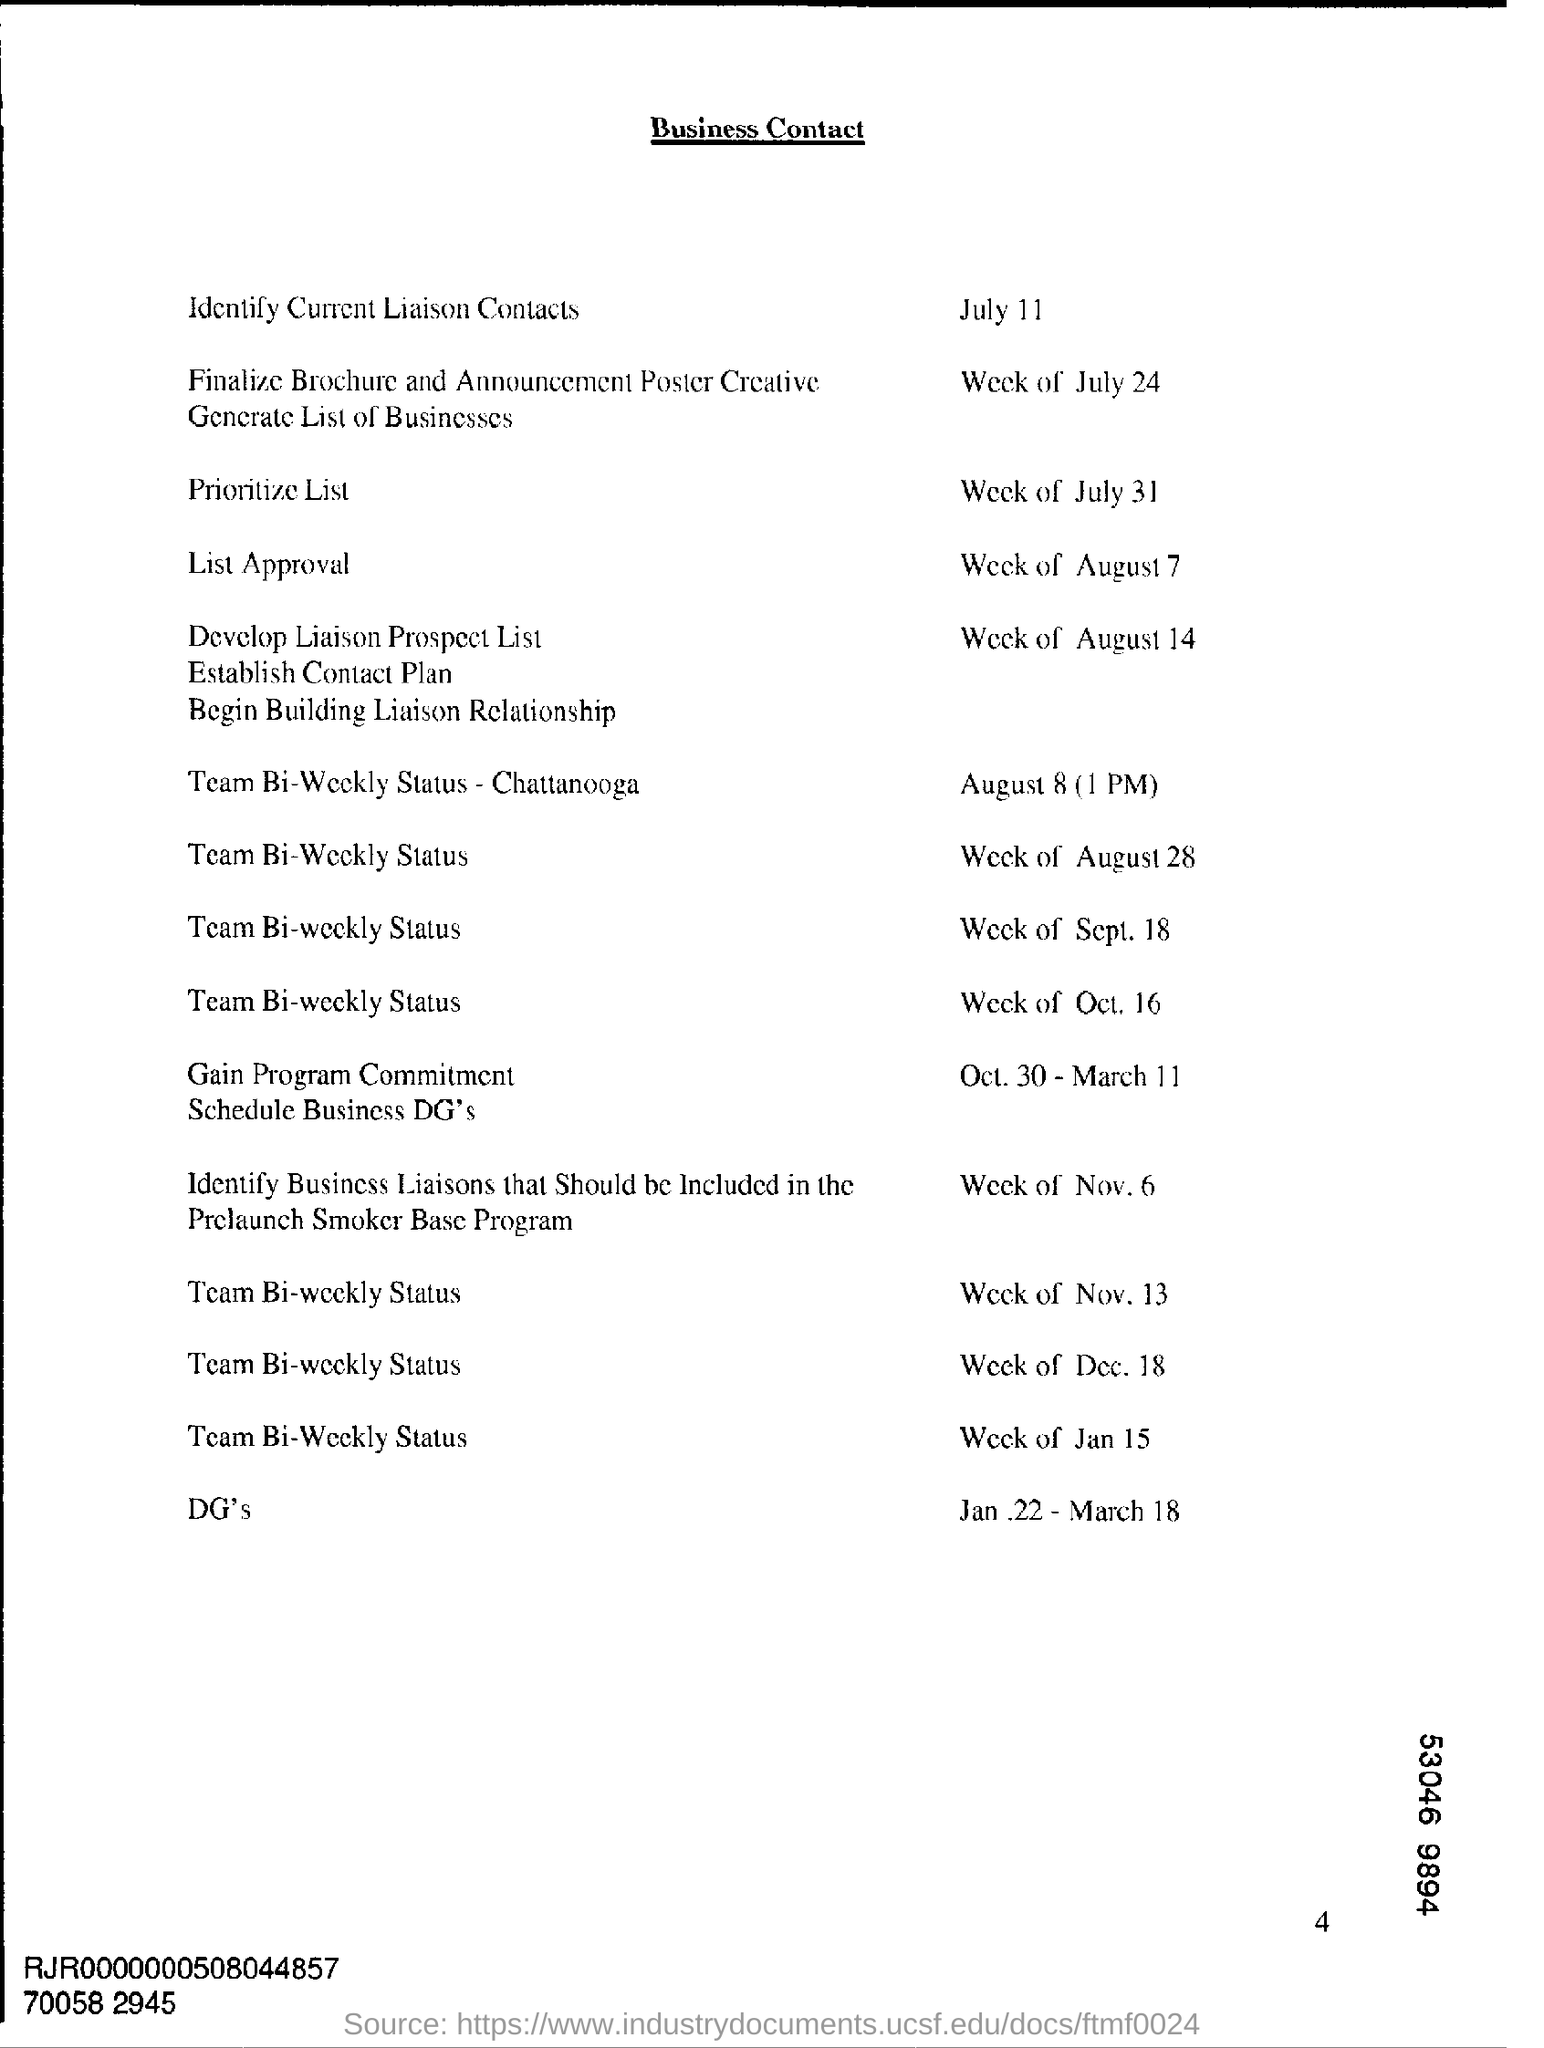Specify some key components in this picture. The heading of the document is 'Business Contact'. 